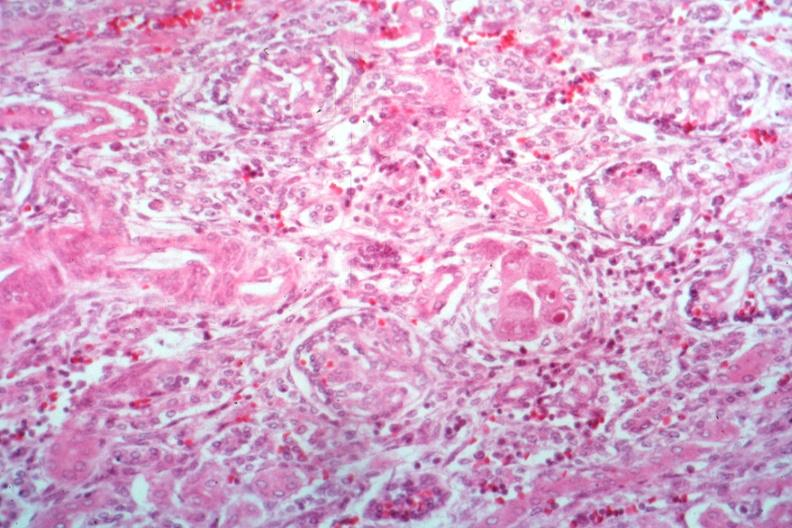s cytomegalovirus present?
Answer the question using a single word or phrase. Yes 